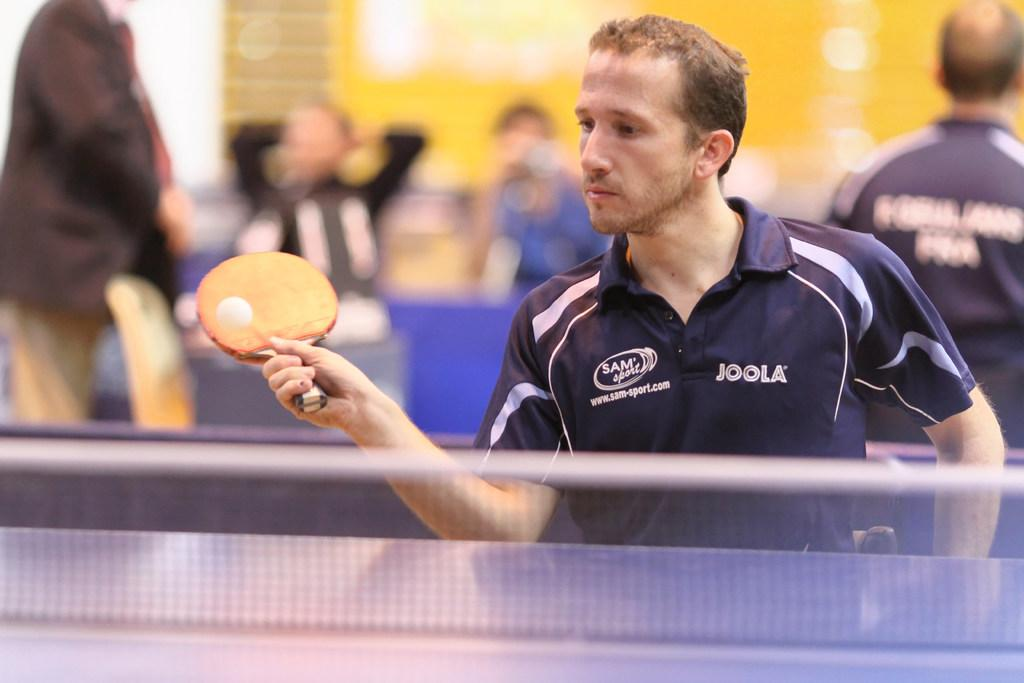<image>
Give a short and clear explanation of the subsequent image. A man playing ping pong has the word JOOLA on the front. 